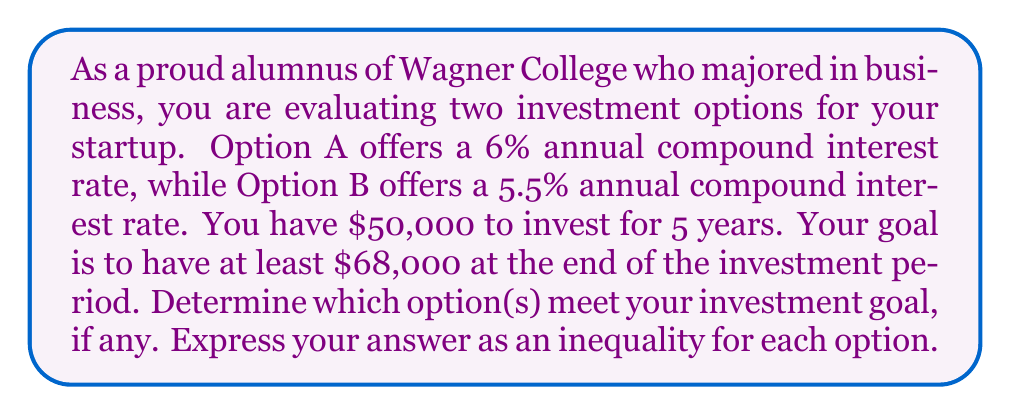What is the answer to this math problem? To solve this problem, we need to use the compound interest formula and compare the results to the desired amount. The compound interest formula is:

$$A = P(1 + r)^t$$

Where:
$A$ = Final amount
$P$ = Principal (initial investment)
$r$ = Annual interest rate (as a decimal)
$t$ = Time in years

Let's evaluate each option:

Option A (6% interest rate):
$$A_A = 50000(1 + 0.06)^5$$
$$A_A = 50000(1.33823)$$
$$A_A = 66911.50$$

Option B (5.5% interest rate):
$$A_B = 50000(1 + 0.055)^5$$
$$A_B = 50000(1.30704)$$
$$A_B = 65352.00$$

Now, we need to compare these results to our goal of $68,000:

Option A: $66911.50 < 68000$
Option B: $65352.00 < 68000$

We can express these as inequalities:

Option A: $50000(1 + 0.06)^5 < 68000$
Option B: $50000(1 + 0.055)^5 < 68000$
Answer: Neither option meets the investment goal. The inequalities are:

Option A: $50000(1 + 0.06)^5 < 68000$
Option B: $50000(1 + 0.055)^5 < 68000$ 